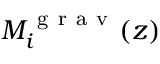Convert formula to latex. <formula><loc_0><loc_0><loc_500><loc_500>M _ { i } ^ { g r a v } ( z )</formula> 